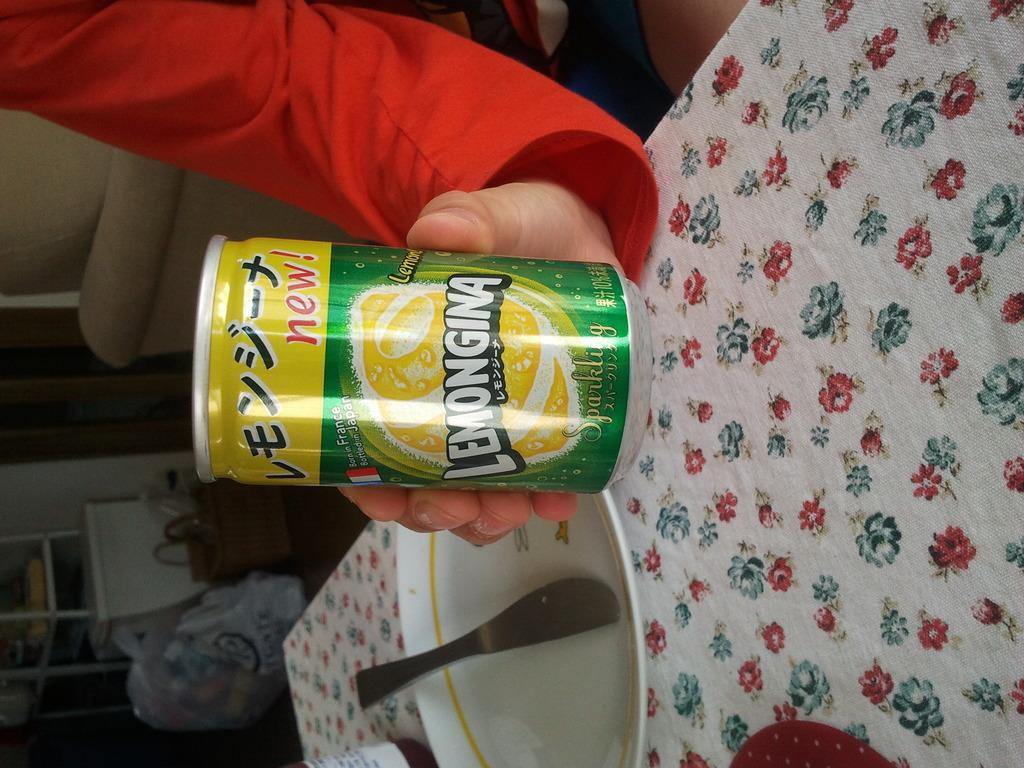<image>
Relay a brief, clear account of the picture shown. A person holds a can reading Lemongina on the label 